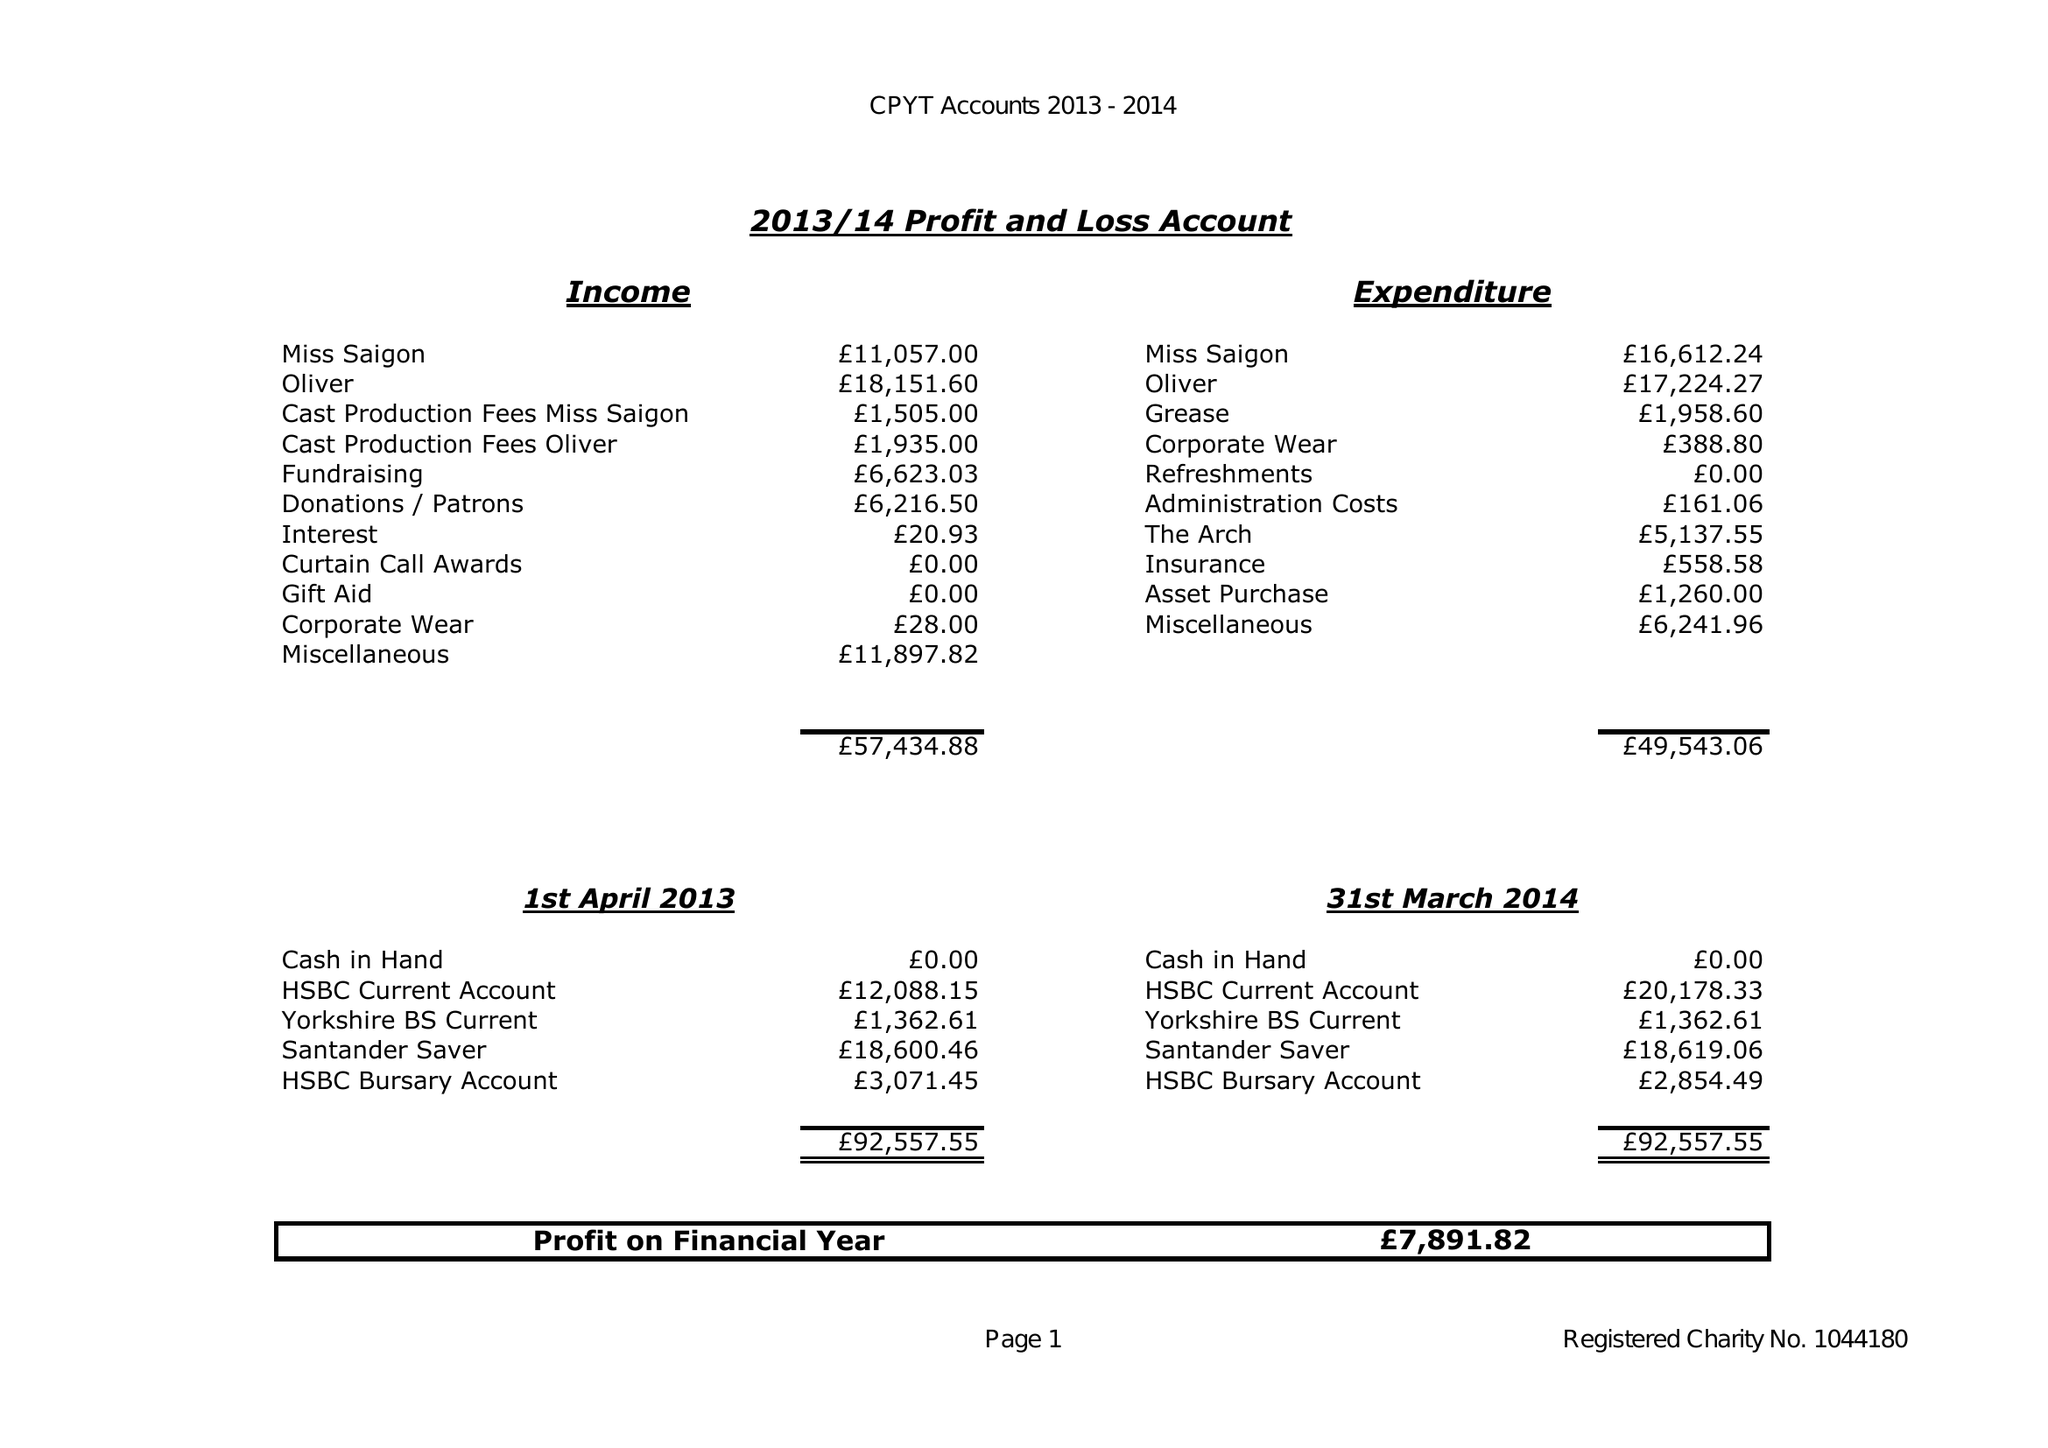What is the value for the report_date?
Answer the question using a single word or phrase. 2014-03-31 